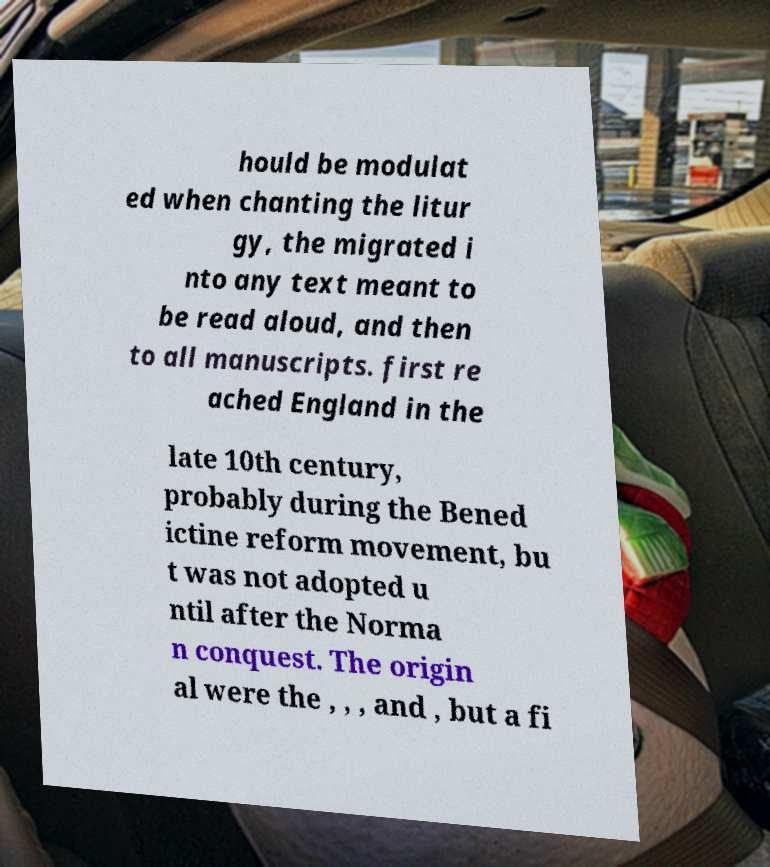Can you accurately transcribe the text from the provided image for me? hould be modulat ed when chanting the litur gy, the migrated i nto any text meant to be read aloud, and then to all manuscripts. first re ached England in the late 10th century, probably during the Bened ictine reform movement, bu t was not adopted u ntil after the Norma n conquest. The origin al were the , , , and , but a fi 